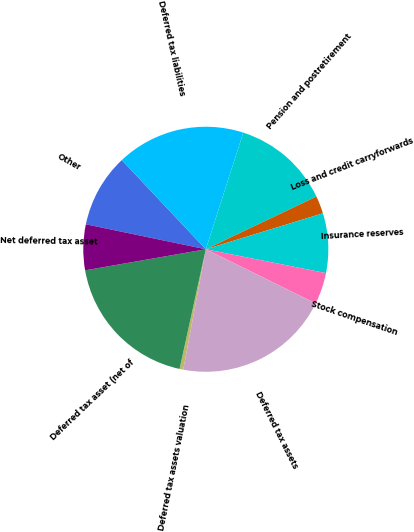Convert chart. <chart><loc_0><loc_0><loc_500><loc_500><pie_chart><fcel>Other<fcel>Deferred tax liabilities<fcel>Pension and postretirement<fcel>Loss and credit carryforwards<fcel>Insurance reserves<fcel>Stock compensation<fcel>Deferred tax assets<fcel>Deferred tax assets valuation<fcel>Deferred tax asset (net of<fcel>Net deferred tax asset<nl><fcel>9.71%<fcel>16.97%<fcel>12.98%<fcel>2.33%<fcel>7.86%<fcel>4.17%<fcel>20.66%<fcel>0.49%<fcel>18.81%<fcel>6.02%<nl></chart> 